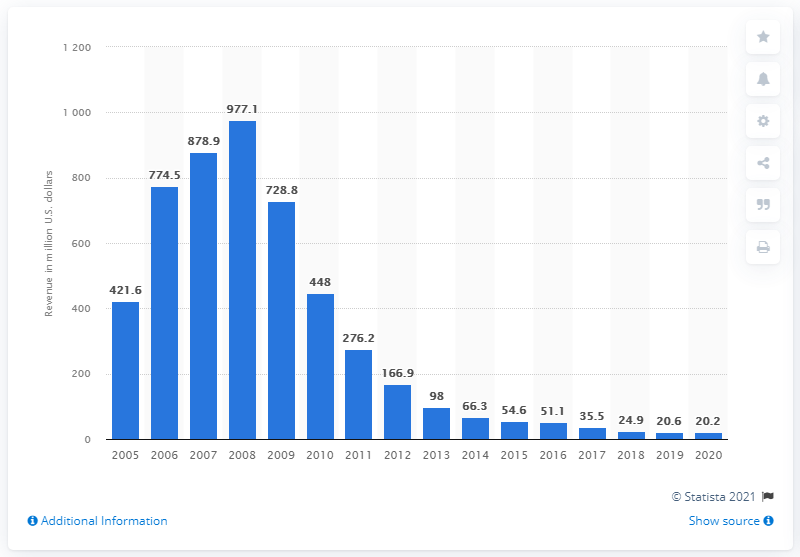Indicate a few pertinent items in this graphic. In 2013, the source reclassified the mobile music revenue category to include only ringbacks and ringtones. The revenue from mobile music in the previous year was 20.6.. In 2020, the mobile music revenue was 20.2. 